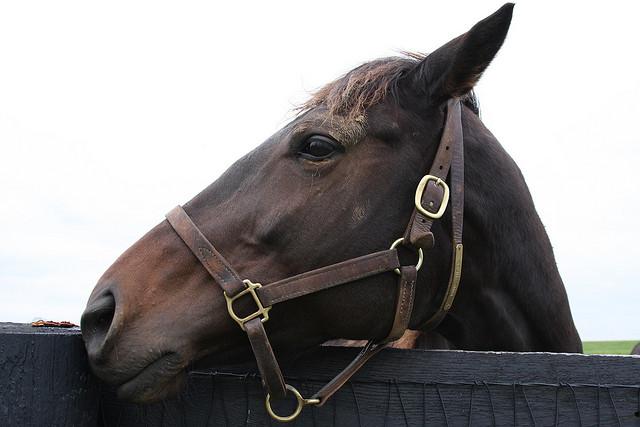Is this horse a metal winner?
Be succinct. No. Which way is the horse looking?
Give a very brief answer. Left. Are the horse's eyes open?
Keep it brief. Yes. 